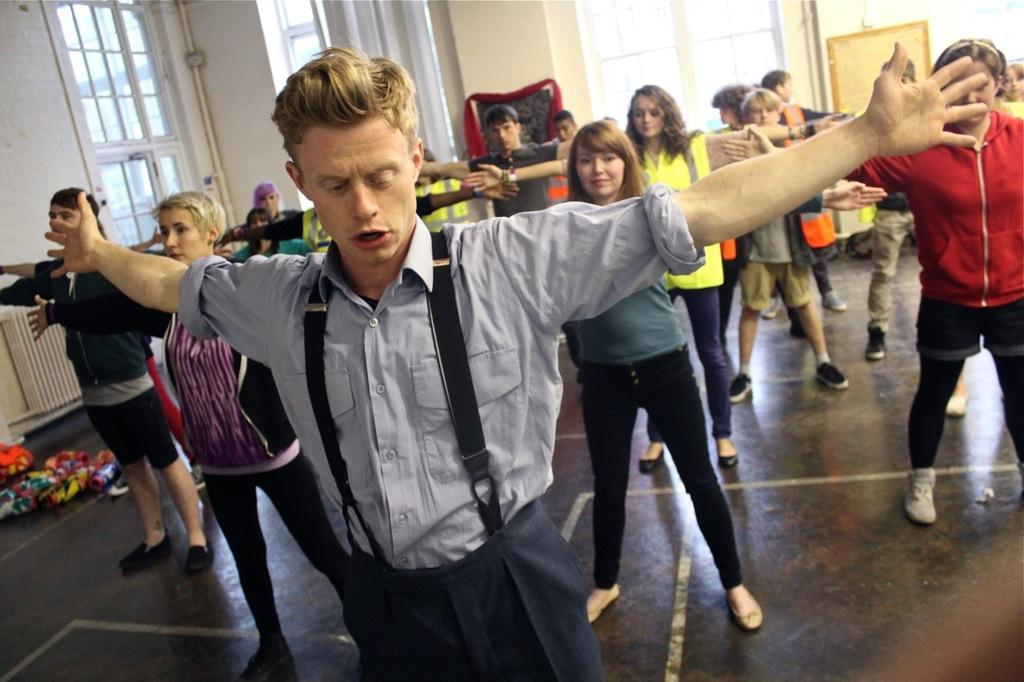What are the persons at the bottom of the image doing? The persons at the bottom of the image are doing exercise on a floor. What can be seen in the background of the image? There are windows, a mirror, and a wall in the background of the image. What are the persons wearing while exercising? The persons are wearing different color dresses. What arithmetic problem are the girls solving in the image? There are no girls or arithmetic problems present in the image; it features persons doing exercise in different color dresses. What type of noise can be heard coming from the persons in the image? There is no information about any noise in the image, as it only shows persons exercising and the background elements. 